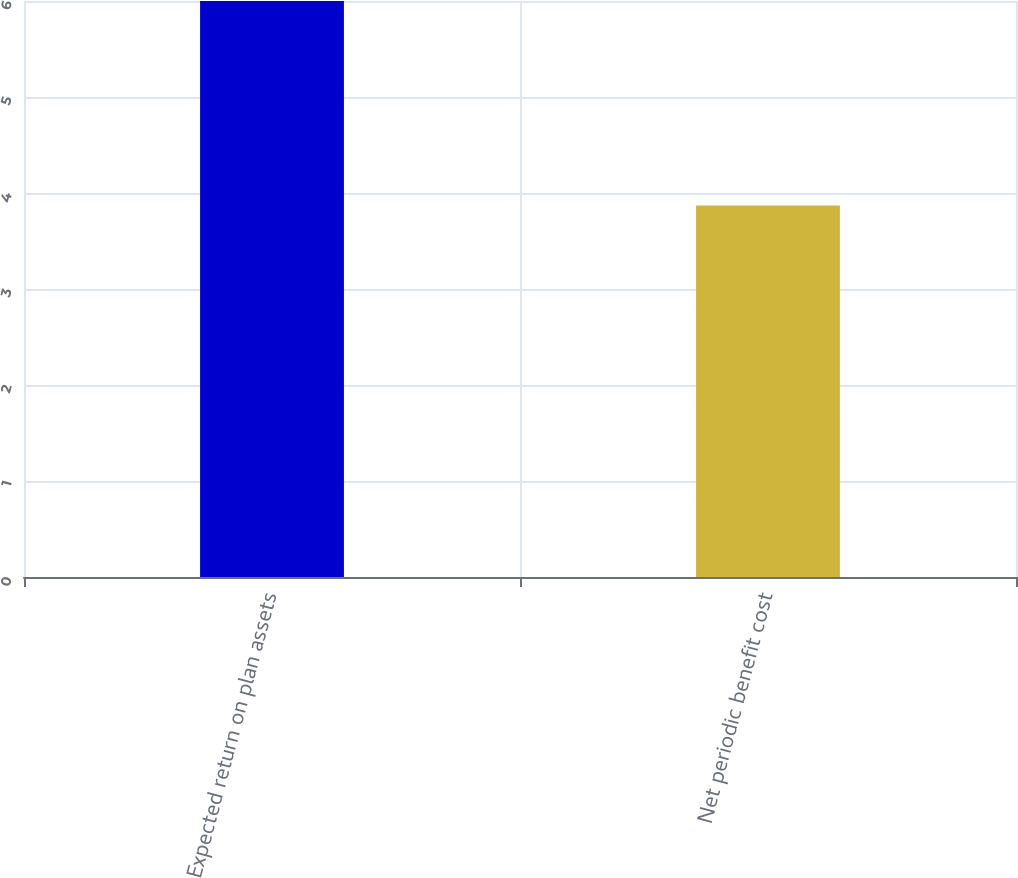Convert chart to OTSL. <chart><loc_0><loc_0><loc_500><loc_500><bar_chart><fcel>Expected return on plan assets<fcel>Net periodic benefit cost<nl><fcel>6<fcel>3.87<nl></chart> 